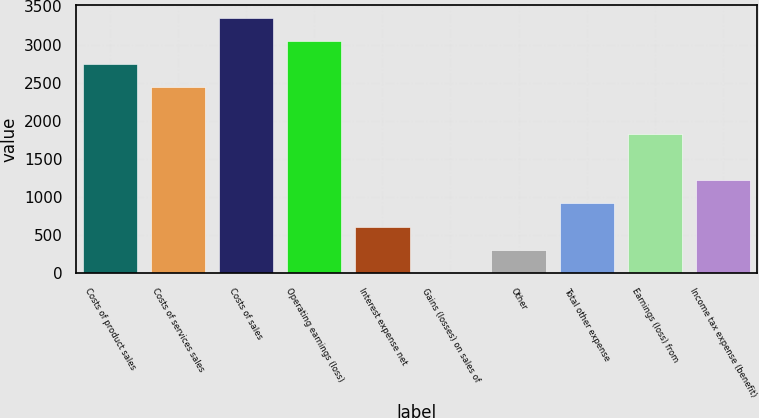Convert chart to OTSL. <chart><loc_0><loc_0><loc_500><loc_500><bar_chart><fcel>Costs of product sales<fcel>Costs of services sales<fcel>Costs of sales<fcel>Operating earnings (loss)<fcel>Interest expense net<fcel>Gains (losses) on sales of<fcel>Other<fcel>Total other expense<fcel>Earnings (loss) from<fcel>Income tax expense (benefit)<nl><fcel>2745.5<fcel>2441<fcel>3354.5<fcel>3050<fcel>614<fcel>5<fcel>309.5<fcel>918.5<fcel>1832<fcel>1223<nl></chart> 